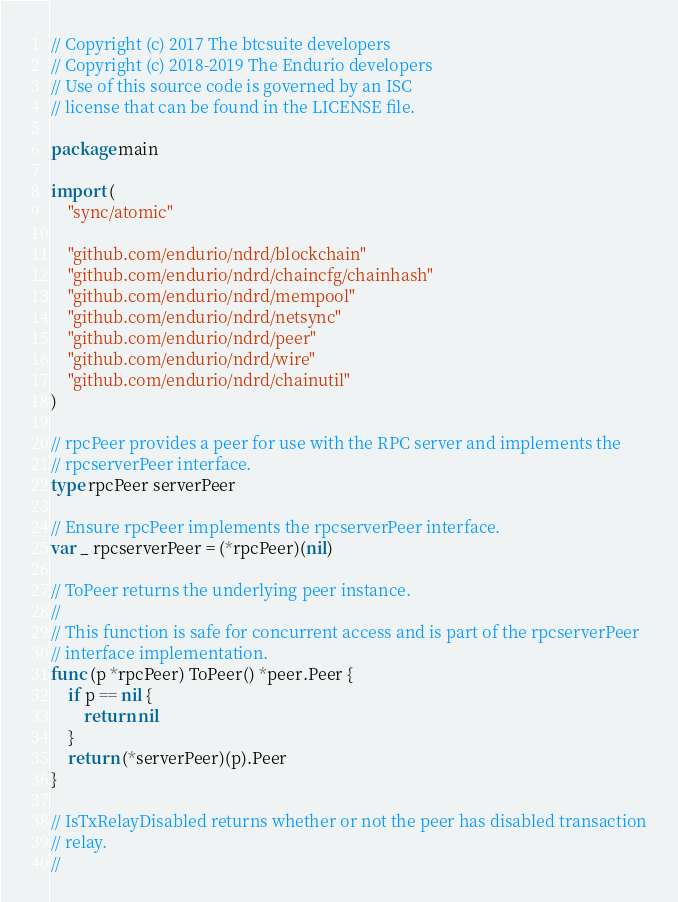Convert code to text. <code><loc_0><loc_0><loc_500><loc_500><_Go_>// Copyright (c) 2017 The btcsuite developers
// Copyright (c) 2018-2019 The Endurio developers
// Use of this source code is governed by an ISC
// license that can be found in the LICENSE file.

package main

import (
	"sync/atomic"

	"github.com/endurio/ndrd/blockchain"
	"github.com/endurio/ndrd/chaincfg/chainhash"
	"github.com/endurio/ndrd/mempool"
	"github.com/endurio/ndrd/netsync"
	"github.com/endurio/ndrd/peer"
	"github.com/endurio/ndrd/wire"
	"github.com/endurio/ndrd/chainutil"
)

// rpcPeer provides a peer for use with the RPC server and implements the
// rpcserverPeer interface.
type rpcPeer serverPeer

// Ensure rpcPeer implements the rpcserverPeer interface.
var _ rpcserverPeer = (*rpcPeer)(nil)

// ToPeer returns the underlying peer instance.
//
// This function is safe for concurrent access and is part of the rpcserverPeer
// interface implementation.
func (p *rpcPeer) ToPeer() *peer.Peer {
	if p == nil {
		return nil
	}
	return (*serverPeer)(p).Peer
}

// IsTxRelayDisabled returns whether or not the peer has disabled transaction
// relay.
//</code> 